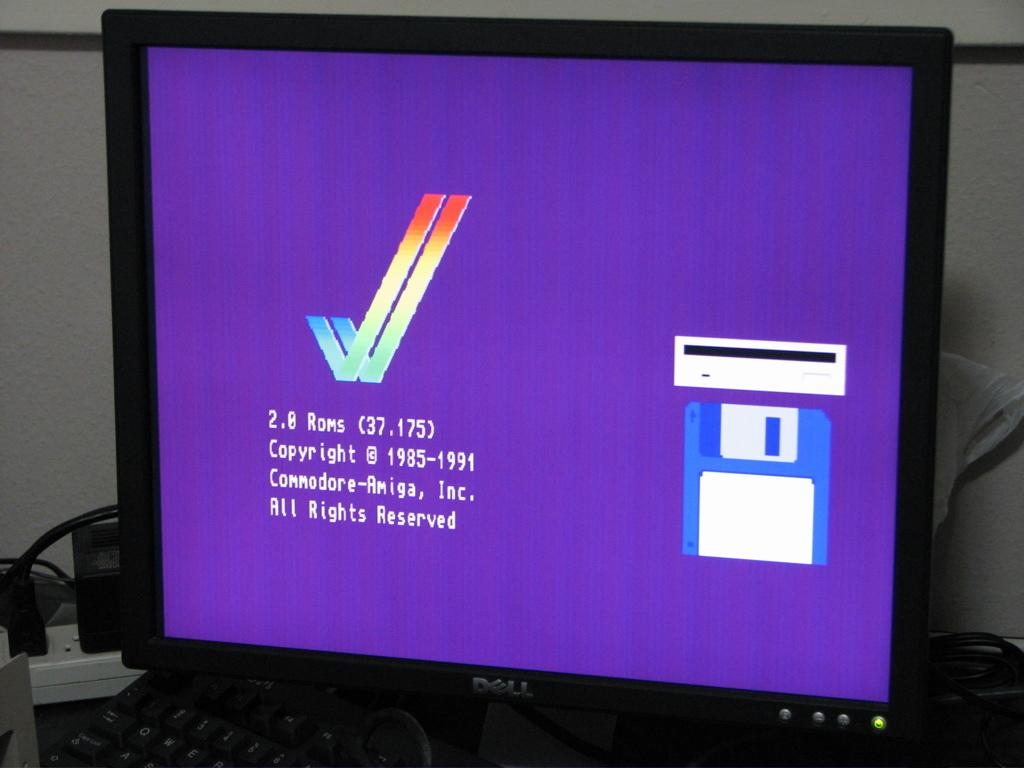<image>
Provide a brief description of the given image. A computer monitor with a purple background that has the copy right info on it in white letters. 